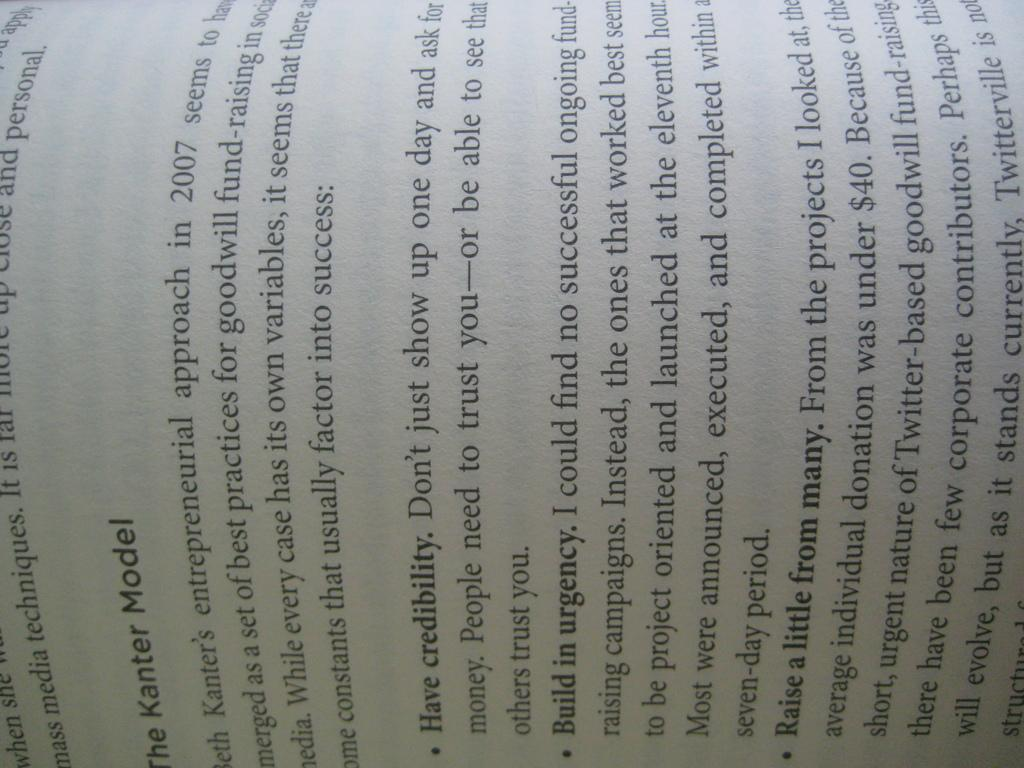<image>
Present a compact description of the photo's key features. A page of a book is pictured sideways, some of the text reads the Kanter Model. 